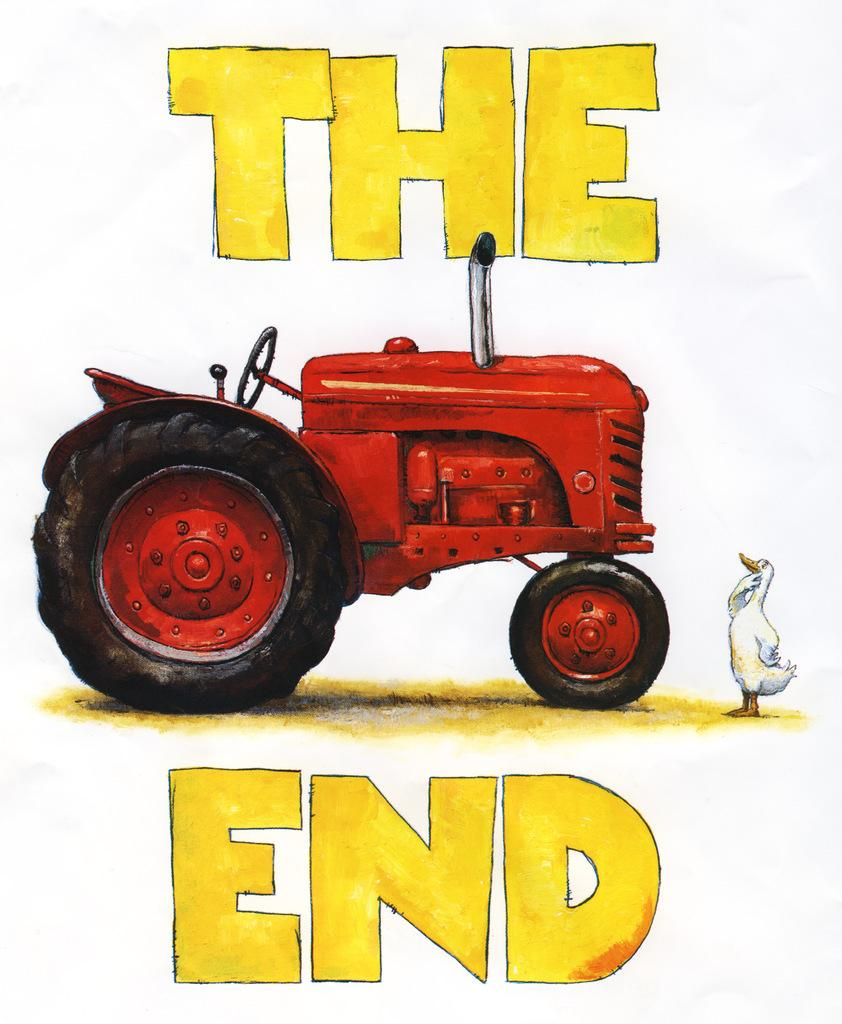What is the main subject in the center of the image? There is a paper in the center of the image. What is depicted on the paper? The paper has a drawing of a bird and a drawing of a tractor on it. What color is the tractor in the drawing? The tractor is red in color. What words are written on the paper? The words "The End" are written on the paper. What type of summer activity is depicted in the image? There is no summer activity depicted in the image; it features a paper with drawings of a bird and a tractor, as well as the words "The End." How does the kiss affect the tractor in the image? There is no kiss present in the image; it features a paper with drawings of a bird and a tractor, as well as the words "The End." 